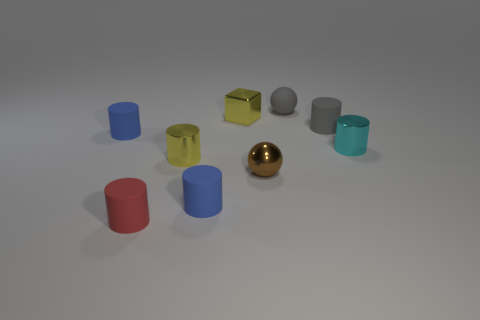Are there an equal number of small blue rubber cylinders behind the small gray ball and small cyan cylinders?
Ensure brevity in your answer.  No. What number of cylinders are both right of the yellow metallic cylinder and in front of the gray matte cylinder?
Your answer should be very brief. 2. What is the size of the other metal thing that is the same shape as the cyan object?
Provide a succinct answer. Small. How many other spheres are the same material as the small brown sphere?
Make the answer very short. 0. Are there fewer tiny red rubber objects behind the small gray matte cylinder than red cylinders?
Your answer should be compact. Yes. What number of cyan cylinders are there?
Your answer should be compact. 1. How many other small blocks are the same color as the small metallic cube?
Make the answer very short. 0. Is the shape of the tiny red rubber object the same as the tiny brown metal object?
Ensure brevity in your answer.  No. There is a blue rubber cylinder that is behind the metallic cylinder to the right of the small metallic ball; what is its size?
Ensure brevity in your answer.  Small. Are there any cylinders that have the same size as the brown metal object?
Offer a very short reply. Yes. 